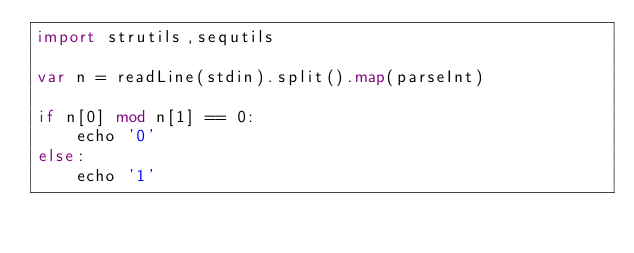<code> <loc_0><loc_0><loc_500><loc_500><_Nim_>import strutils,sequtils

var n = readLine(stdin).split().map(parseInt)

if n[0] mod n[1] == 0:
    echo '0'
else:
    echo '1'</code> 